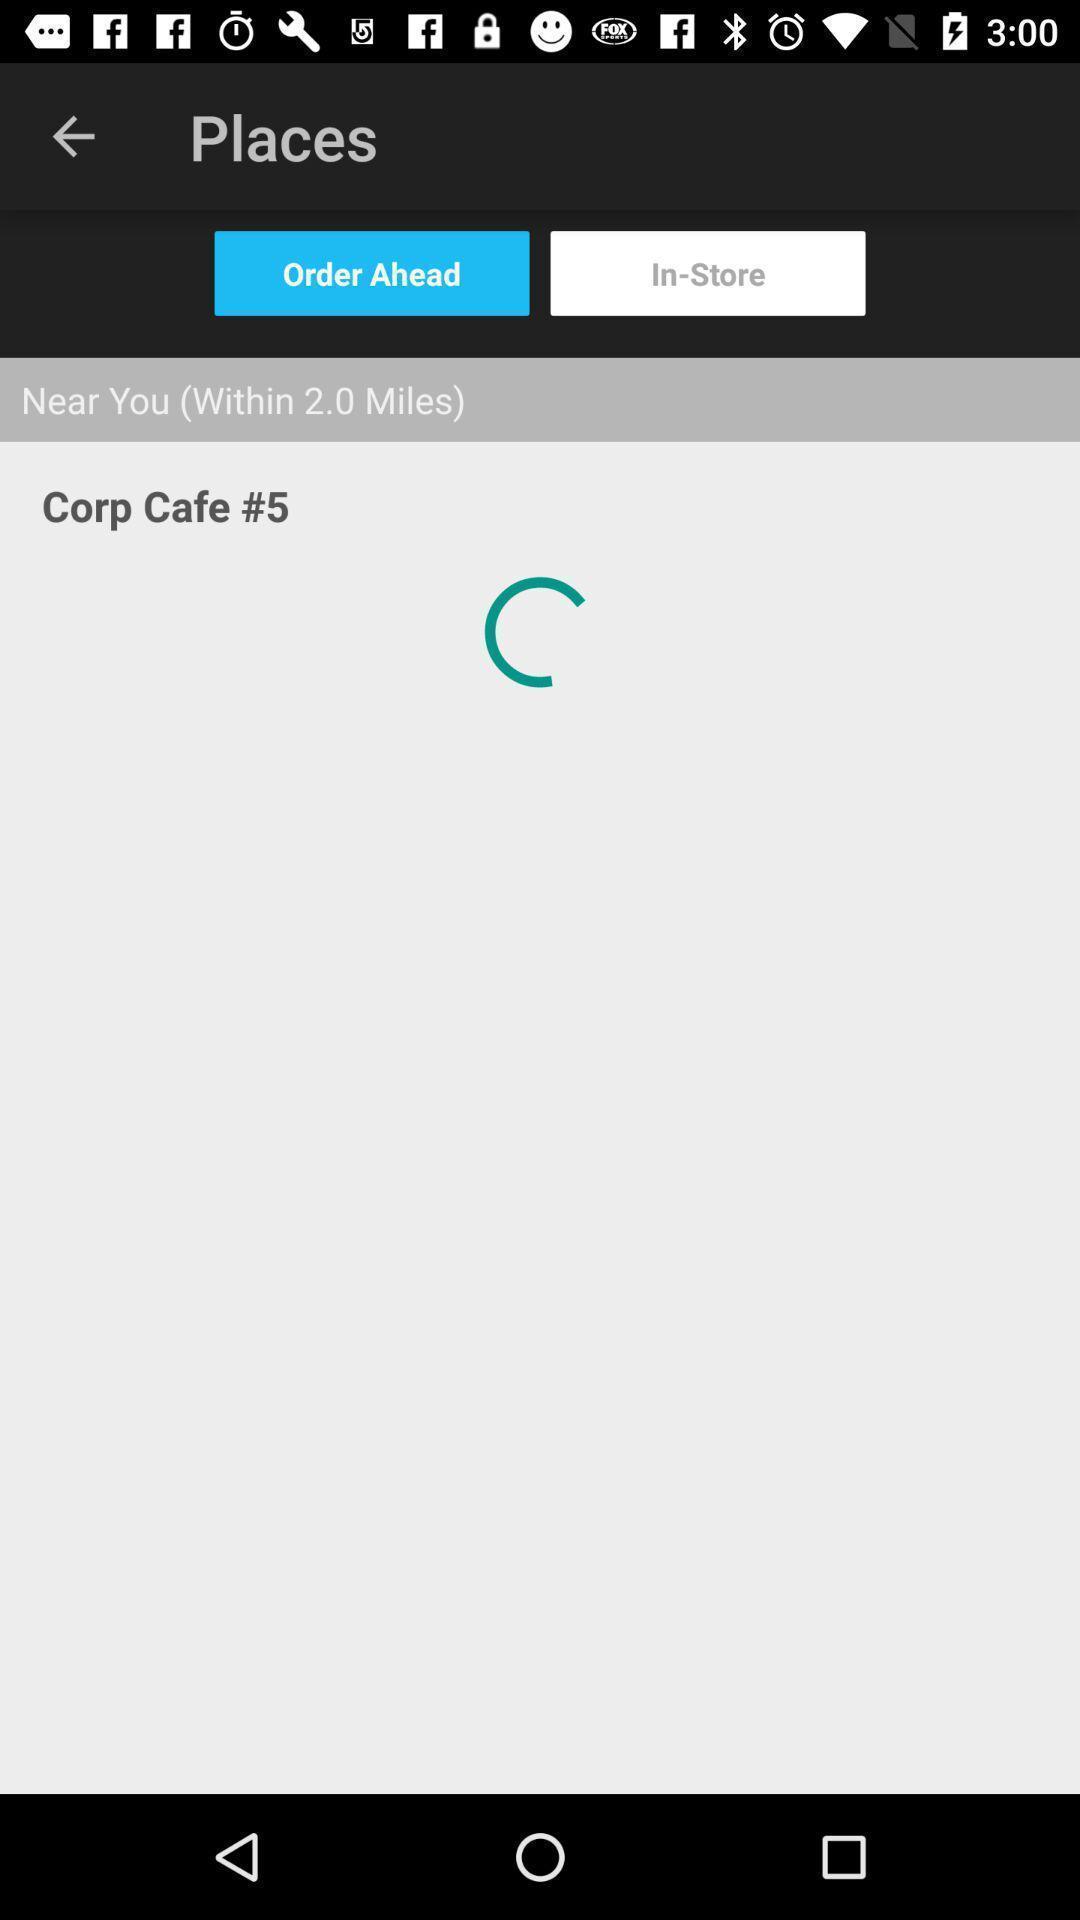Describe this image in words. Social app for ordering food. 